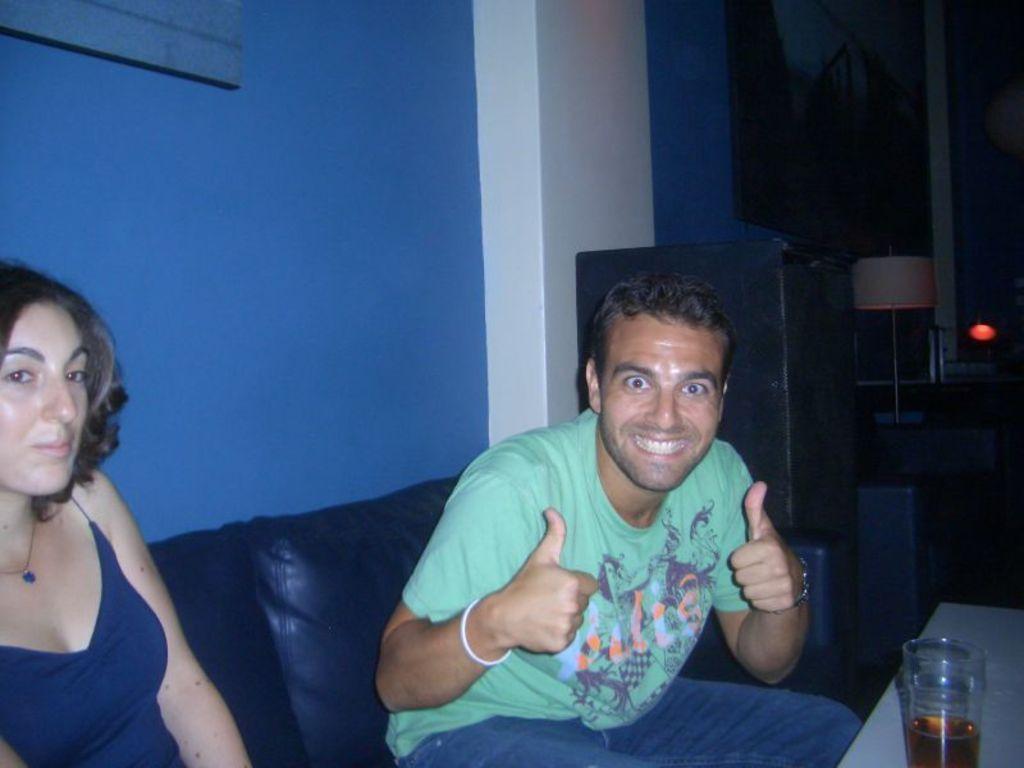In one or two sentences, can you explain what this image depicts? This is the man and woman sitting on the couch and smiling. I can see a glass of liquid, which is placed on the table. This looks like a lamp. I can see a frame, which is attached to the wall. I think this is an object. 